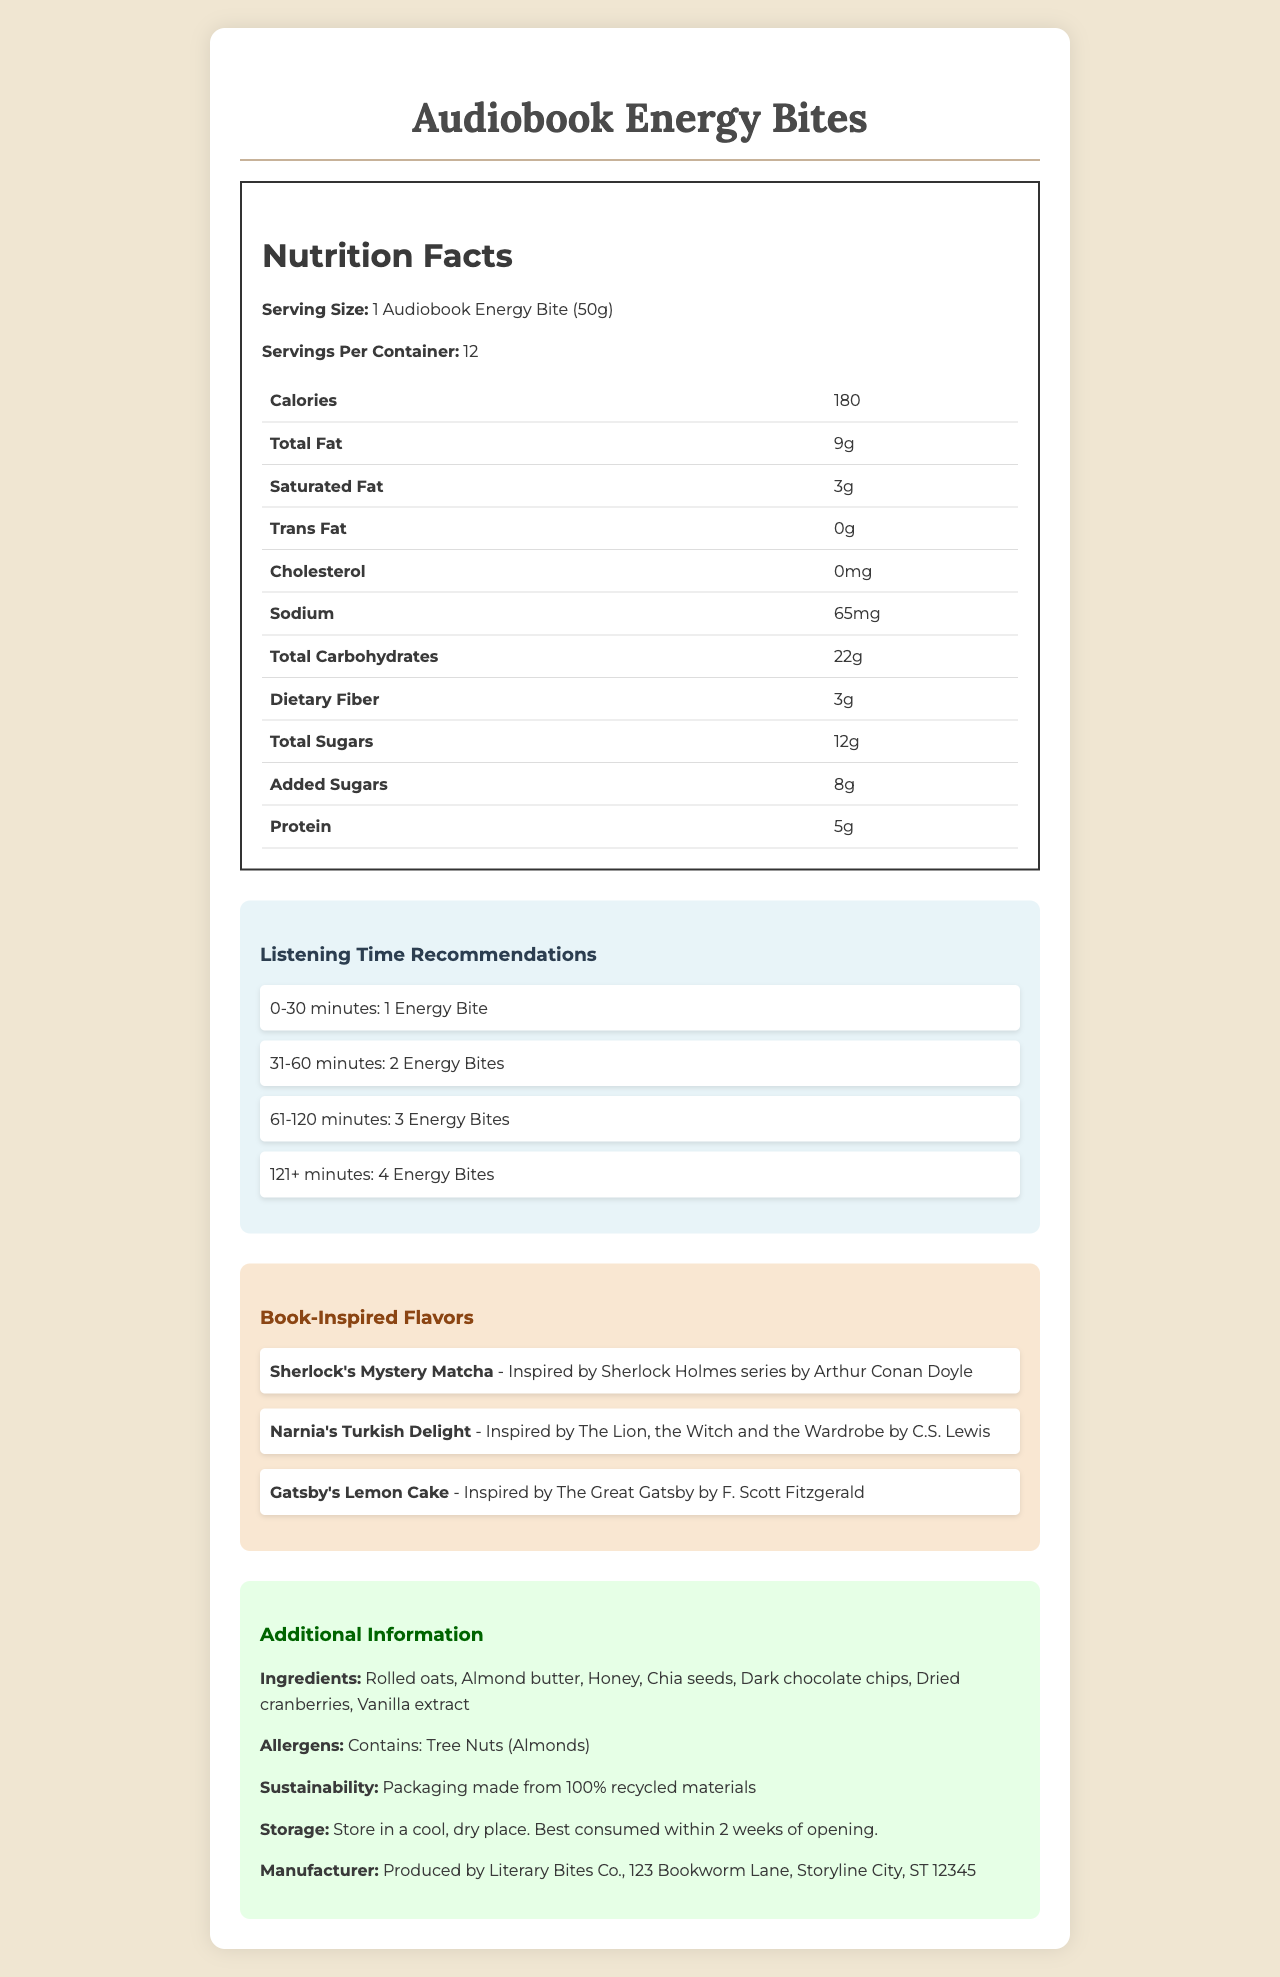Who is the manufacturer of Audiobook Energy Bites? The document clearly states under the "Additional Information" section that the manufacturer is "Produced by Literary Bites Co., 123 Bookworm Lane, Storyline City, ST 12345."
Answer: Literary Bites Co. What are the book-inspired flavors available for Audiobook Energy Bites? The "Book-Inspired Flavors" section lists these flavors: Sherlock's Mystery Matcha, Narnia's Turkish Delight, and Gatsby's Lemon Cake.
Answer: Sherlock's Mystery Matcha, Narnia's Turkish Delight, Gatsby's Lemon Cake What is the serving size for one Audiobook Energy Bite? The serving size is clearly mentioned in the "Nutrition Facts" section as "1 Audiobook Energy Bite (50g)."
Answer: 1 Audiobook Energy Bite (50g) How much protein does one serving of Audiobook Energy Bites contain? The "Nutrition Facts" table lists the protein content as 5g per serving.
Answer: 5g How should Audiobook Energy Bites be stored? The "Additional Information" section provides storage instructions, stating "Store in a cool, dry place. Best consumed within 2 weeks of opening."
Answer: Store in a cool, dry place. Best consumed within 2 weeks of opening. For a listening session of 45 minutes, how many energy bites are recommended? A. 1 Energy Bite B. 2 Energy Bites C. 3 Energy Bites The "Listening Time Recommendations" section shows that for a duration of 31-60 minutes, 2 Energy Bites are recommended.
Answer: B. 2 Energy Bites Which ingredient listed is an allergen? A. Rolled Oats B. Almond Butter C. Chia Seeds The "Allergens" section mentions "Contains: Tree Nuts (Almonds)," and Almond Butter is listed among the ingredients.
Answer: B. Almond Butter How many servings are there per container? The "Nutrition Facts" section specifies that there are 12 servings per container.
Answer: 12 Does this product contain any trans fat? The "Nutrition Facts" section indicates that the product contains 0g of trans fat.
Answer: No Describe the main idea of the document. The document is structured to give a comprehensive overview of the Audiobook Energy Bites, covering all essential aspects such as nutritional content, listening recommendations, ingredients, and flavors inspired by books.
Answer: The document provides detailed information about the Audiobook Energy Bites, including nutrition facts, listening time recommendations, book-inspired flavors, ingredients, allergens, sustainability info, storage instructions, and manufacturer details. Which book inspired the flavor "Narnia's Turkish Delight"? The "Book-Inspired Flavors" section lists "Narnia's Turkish Delight" as being inspired by "The Lion, the Witch and the Wardrobe by C.S. Lewis."
Answer: The Lion, the Witch and the Wardrobe by C.S. Lewis Is the packaging for Audiobook Energy Bites sustainable? The "Additional Information" section specifies that the packaging is made from 100% recycled materials.
Answer: Yes What is the amount of dietary fiber per serving? The "Nutrition Facts" table lists the dietary fiber content as 3g per serving.
Answer: 3g What is the recommended number of energy bites for a listening session of 2 hours? The "Listening Time Recommendations" section shows that for a duration of 61-120 minutes, 3 Energy Bites are recommended.
Answer: 3 Energy Bites How much sodium does one serving contain? The "Nutrition Facts" section lists the sodium content as 65mg per serving.
Answer: 65mg What is the calorie count per serving of Audiobook Energy Bites? The "Nutrition Facts" section clearly states that each serving contains 180 calories.
Answer: 180 calories For a listening session of 15 minutes, which of the following is the recommended number of bites? A. 1 Energy Bite B. 2 Energy Bites C. 3 Energy Bites D. 4 Energy Bites The "Listening Time Recommendations" section shows that for a duration of 0-30 minutes, 1 Energy Bite is recommended.
Answer: A. 1 Energy Bite What book inspired the flavor "Sherlock's Mystery Matcha"? The "Book-Inspired Flavors" section lists "Sherlock's Mystery Matcha" as being inspired by the "Sherlock Holmes series by Arthur Conan Doyle."
Answer: Sherlock Holmes series by Arthur Conan Doyle How much potassium is there in each serving? The "Nutrition Facts" section lists the potassium content as 150mg per serving.
Answer: 150mg What flavor is inspired by The Great Gatsby? The "Book-Inspired Flavors" section lists "Gatsby's Lemon Cake" as being inspired by "The Great Gatsby by F. Scott Fitzgerald."
Answer: Gatsby's Lemon Cake Who founded Literary Bites Co.? The document does not provide any information about the founder of Literary Bites Co.
Answer: Cannot be determined 